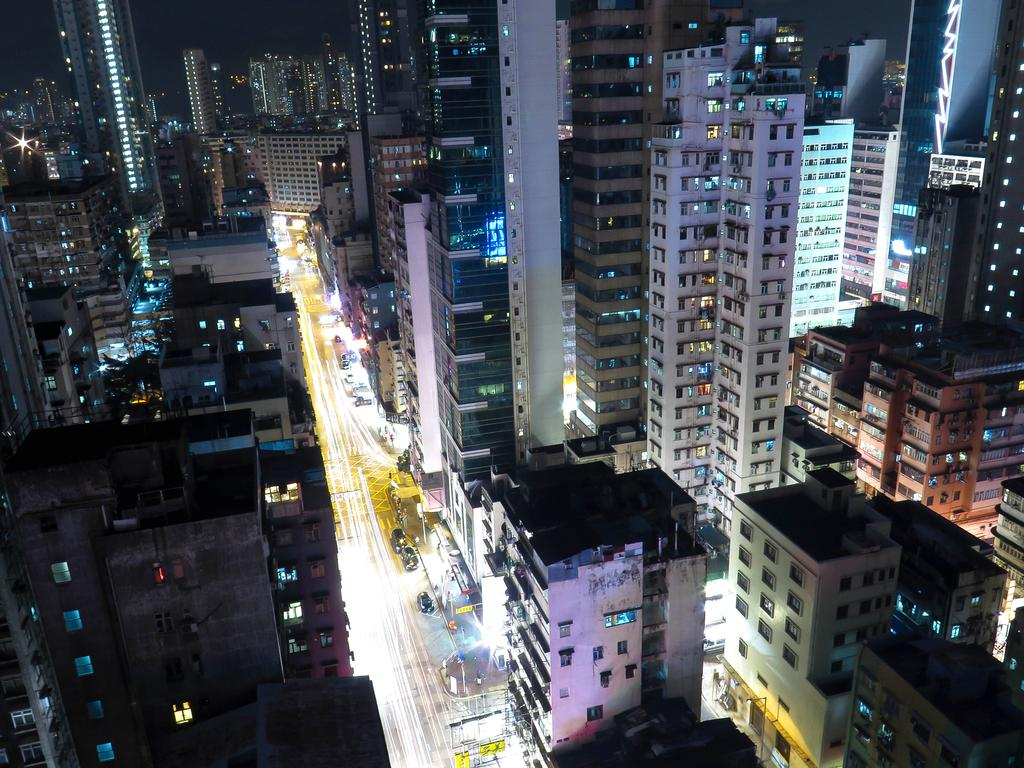What types of structures can be seen in the image? There are multiple buildings in the image. What else can be seen on the road in the image? There are cars parked on the road in the image. How many clocks are hanging on the walls of the buildings in the image? There is no information about clocks in the image, so we cannot determine the number of clocks. What type of lamp is present on the street in the image? There is no lamp present on the street in the image. 